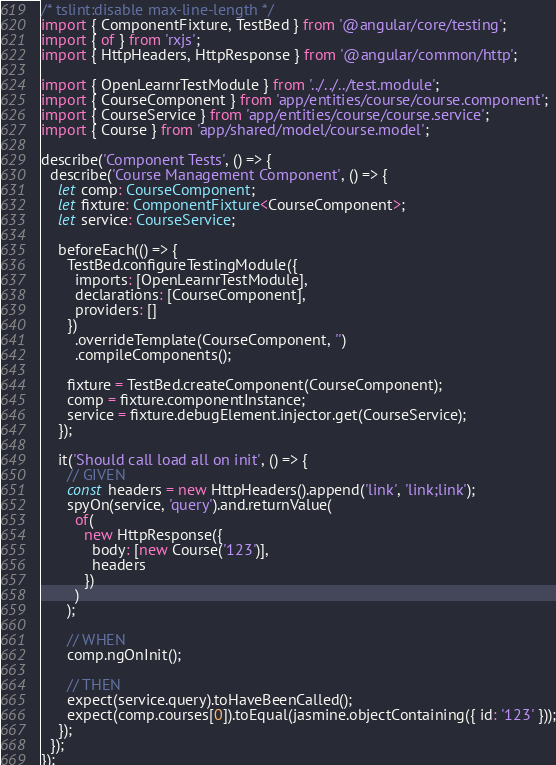Convert code to text. <code><loc_0><loc_0><loc_500><loc_500><_TypeScript_>/* tslint:disable max-line-length */
import { ComponentFixture, TestBed } from '@angular/core/testing';
import { of } from 'rxjs';
import { HttpHeaders, HttpResponse } from '@angular/common/http';

import { OpenLearnrTestModule } from '../../../test.module';
import { CourseComponent } from 'app/entities/course/course.component';
import { CourseService } from 'app/entities/course/course.service';
import { Course } from 'app/shared/model/course.model';

describe('Component Tests', () => {
  describe('Course Management Component', () => {
    let comp: CourseComponent;
    let fixture: ComponentFixture<CourseComponent>;
    let service: CourseService;

    beforeEach(() => {
      TestBed.configureTestingModule({
        imports: [OpenLearnrTestModule],
        declarations: [CourseComponent],
        providers: []
      })
        .overrideTemplate(CourseComponent, '')
        .compileComponents();

      fixture = TestBed.createComponent(CourseComponent);
      comp = fixture.componentInstance;
      service = fixture.debugElement.injector.get(CourseService);
    });

    it('Should call load all on init', () => {
      // GIVEN
      const headers = new HttpHeaders().append('link', 'link;link');
      spyOn(service, 'query').and.returnValue(
        of(
          new HttpResponse({
            body: [new Course('123')],
            headers
          })
        )
      );

      // WHEN
      comp.ngOnInit();

      // THEN
      expect(service.query).toHaveBeenCalled();
      expect(comp.courses[0]).toEqual(jasmine.objectContaining({ id: '123' }));
    });
  });
});
</code> 